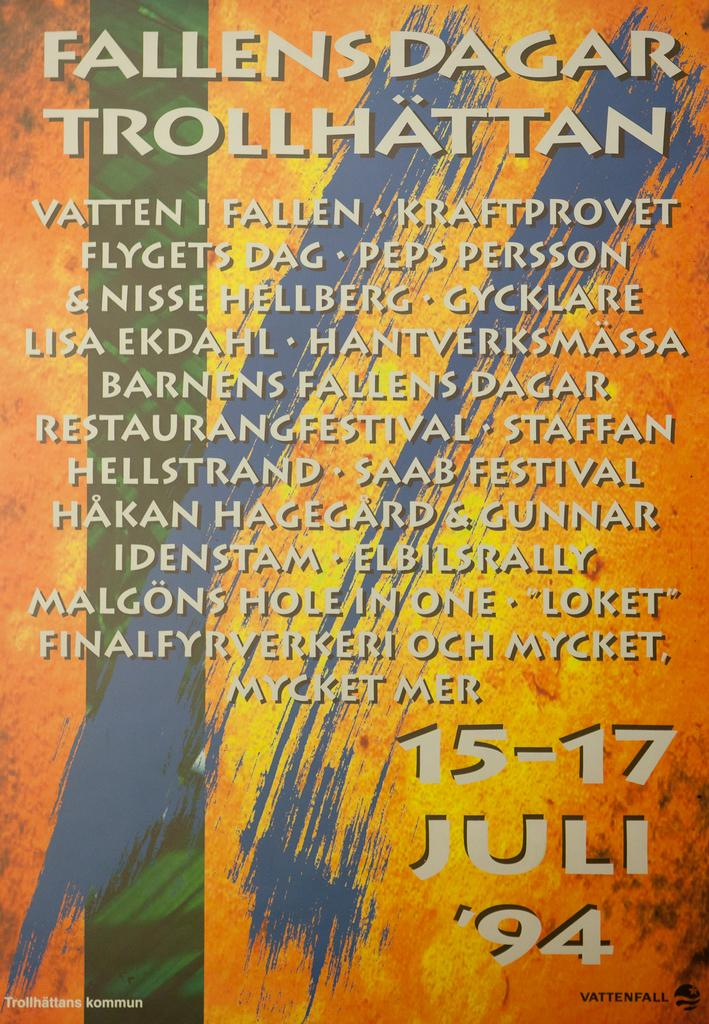<image>
Share a concise interpretation of the image provided. A poster for Fallen Dagar Trollhattan was published by Vattenfall 